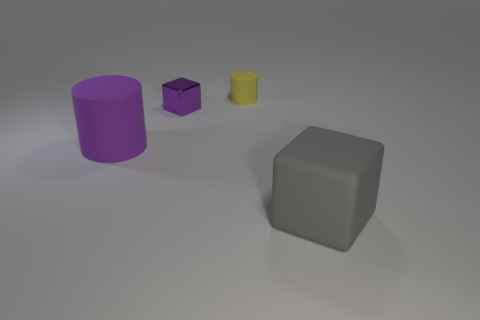What material is the thing that is the same color as the large rubber cylinder?
Ensure brevity in your answer.  Metal. Do the object on the left side of the shiny block and the large block have the same size?
Make the answer very short. Yes. How many large gray matte objects are there?
Give a very brief answer. 1. How many objects are both behind the gray cube and right of the tiny purple block?
Give a very brief answer. 1. Are there any gray balls that have the same material as the big cube?
Make the answer very short. No. What is the large object that is on the left side of the rubber cylinder on the right side of the purple cylinder made of?
Your answer should be compact. Rubber. Are there the same number of small yellow cylinders that are in front of the large gray matte thing and objects that are in front of the large cylinder?
Keep it short and to the point. No. Do the purple rubber object and the tiny purple shiny thing have the same shape?
Provide a short and direct response. No. There is a thing that is on the right side of the purple cylinder and in front of the purple metal thing; what is it made of?
Your answer should be compact. Rubber. How many matte objects are the same shape as the purple shiny thing?
Offer a very short reply. 1. 